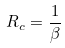<formula> <loc_0><loc_0><loc_500><loc_500>R _ { c } = \frac { 1 } { \beta }</formula> 